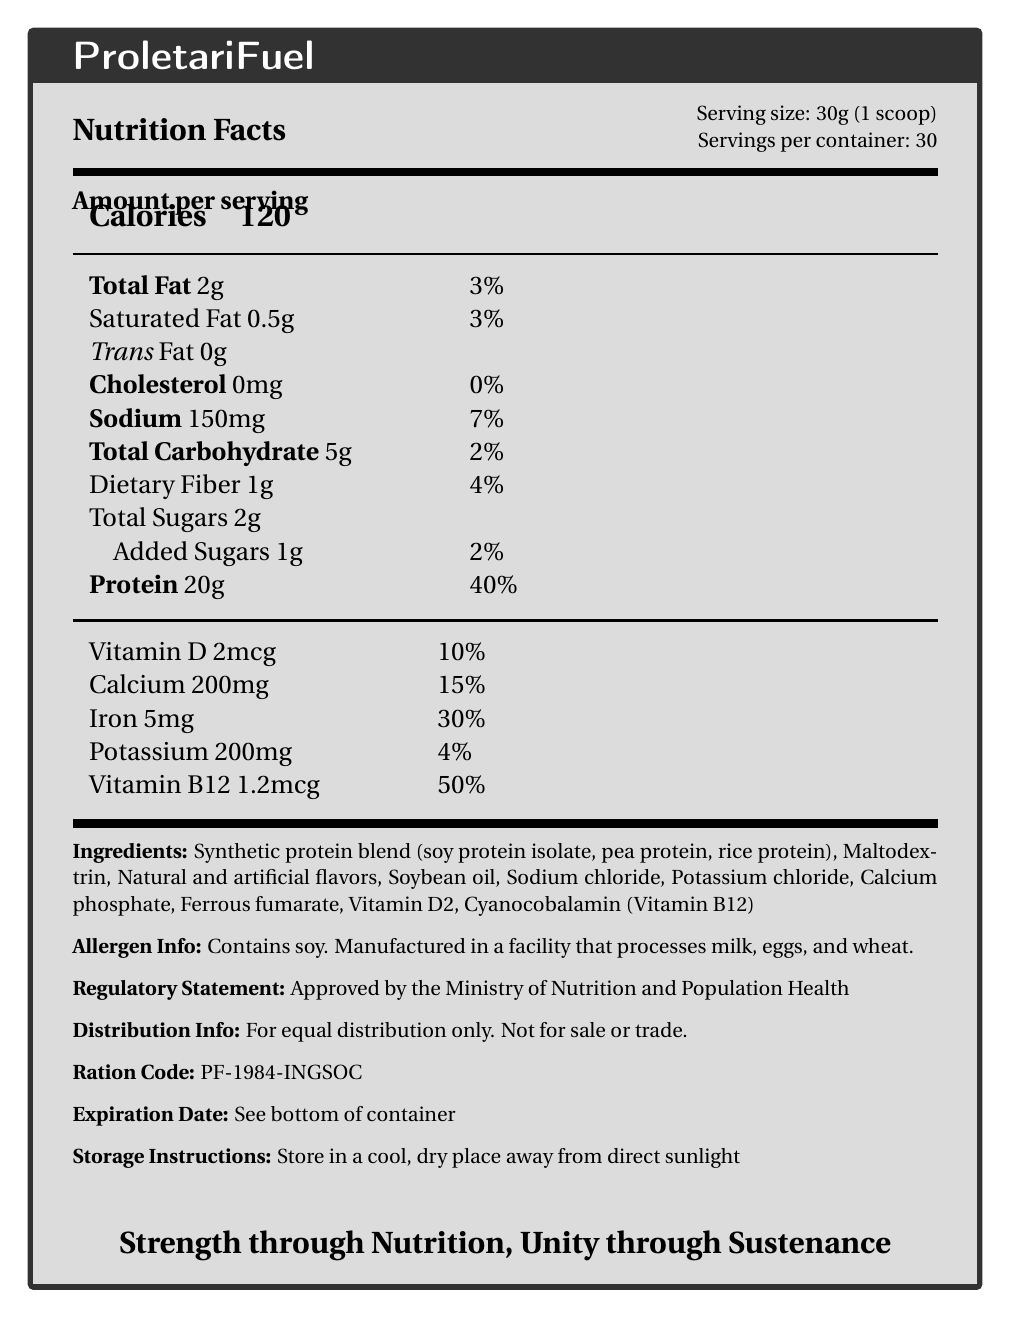what is the serving size for ProletariFuel? The serving size is specified in the top right section of the Nutrition Facts box: "Serving size: 30g (1 scoop)".
Answer: 30g (1 scoop) how many servings are there in one container of ProletariFuel? The number of servings per container is listed directly below the serving size: "Servings per container: 30".
Answer: 30 how many grams of protein are there per serving of ProletariFuel? The amount of protein per serving is listed under the Nutrition Facts section: "Protein 20g".
Answer: 20g what percentage of the daily value of sodium does one serving of ProletariFuel provide? The percentage daily value of sodium is stated next to the amount: "Sodium 150mg 7%".
Answer: 7% how much cholesterol is in one serving of ProletariFuel? The cholesterol content per serving is specified as: "Cholesterol 0mg".
Answer: 0mg what is the slogan written at the bottom of the ProletariFuel document? The slogan is placed at the bottom center of the document and reads: "Strength through Nutrition, Unity through Sustenance".
Answer: Strength through Nutrition, Unity through Sustenance what are the main ingredients in ProletariFuel? The ingredients are listed under the Ingredients section: "Synthetic protein blend (soy protein isolate, pea protein, rice protein), Maltodextrin, Natural and artificial flavors, Soybean oil, Sodium chloride, Potassium chloride, Calcium phosphate, Ferrous fumarate, Vitamin D2, Cyanocobalamin (Vitamin B12)".
Answer: Synthetic protein blend (soy protein isolate, pea protein, rice protein), Maltodextrin, Natural and artificial flavors, Soybean oil, Sodium chloride, Potassium chloride, Calcium phosphate, Ferrous fumarate, Vitamin D2, Cyanocobalamin (Vitamin B12) what is unique about the distribution of ProletariFuel? A. It is primarily sold online. B. It is available only in major supermarkets. C. It is for equal distribution and not for sale or trade. D. It is a premium product targeted at athletes. The distribution info states: "For equal distribution only. Not for sale or trade."
Answer: C what is the daily value percentage of vitamin B12 per serving of ProletariFuel? A. 10% B. 15% C. 30% D. 50% The daily value percentage of vitamin B12 per serving is stated as: "Vitamin B12 1.2mcg 50%".
Answer: D is ProletariFuel gluten-free? The document specifies that it contains soy and is manufactured in a facility that processes milk, eggs, and wheat but doesn’t explicitly mention whether it is gluten-free.
Answer: Cannot be determined is there any iron in ProletariFuel? The Nutrition Facts section lists: "Iron 5mg 30%".
Answer: Yes does ProletariFuel contain any added sugars? The Nutrition Facts section lists "Added Sugars 1g 2%".
Answer: Yes summarize the main purpose of the ProletariFuel document. The document is designed to inform consumers about ProletariFuel's nutritional contents and regulatory status. It highlights the product's nutritional benefits in a totalitarian regime setting, underscoring equal distribution and state approval. The slogan reflects the ideological underpinnings of the product’s use.
Answer: The ProletariFuel document provides detailed nutrition facts for a synthetic protein supplement, specifying serving size, calories, macronutrients, vitamins, and minerals per serving. It includes information on the product’s ingredients, allergen information, regulatory approval, and distribution instructions. The document emphasizes that the product is for equal distribution and not for sale or trade and includes a thematic slogan promoting nutrition and unity. 